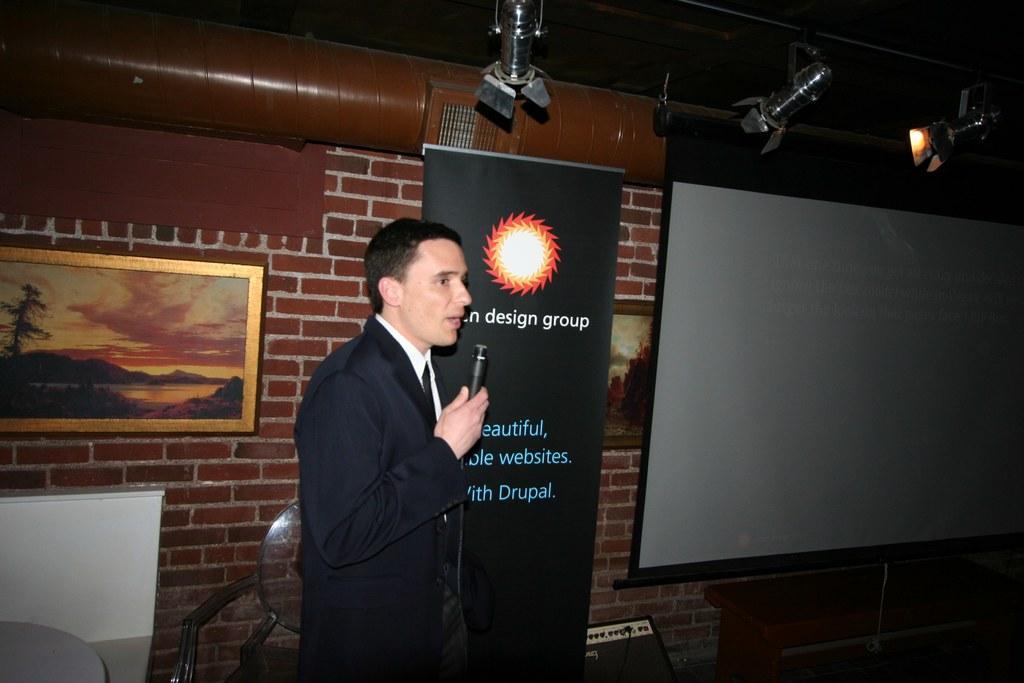Could you give a brief overview of what you see in this image? As we can see in the image there is a person wearing a black color jacket and holding mic. There is a brick wall, lights, photo frame and screen. 